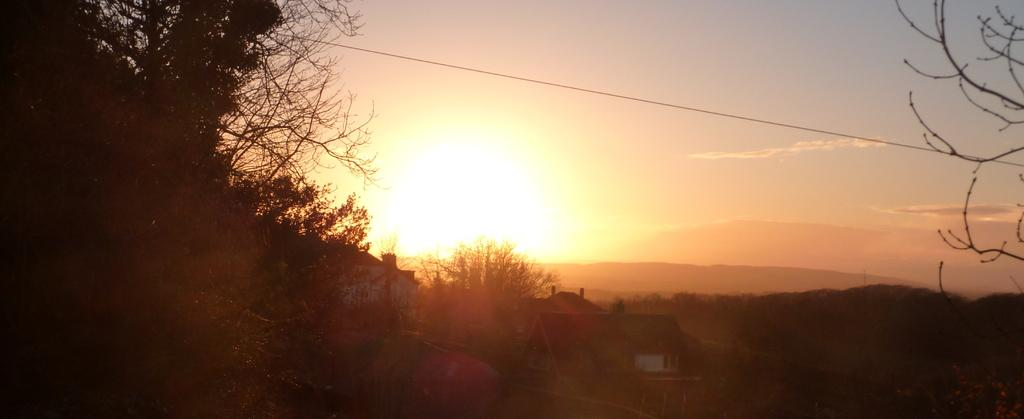What type of vegetation can be seen in the image? There are trees in the image. What type of structures are present in the image? There are houses in the image. What can be seen in the background of the image? There is a hill and the sky visible in the background of the image. Are there any giants visible in the image? There are no giants present in the image. What type of berry can be seen growing on the trees in the image? There are no berries mentioned or visible on the trees in the image. 